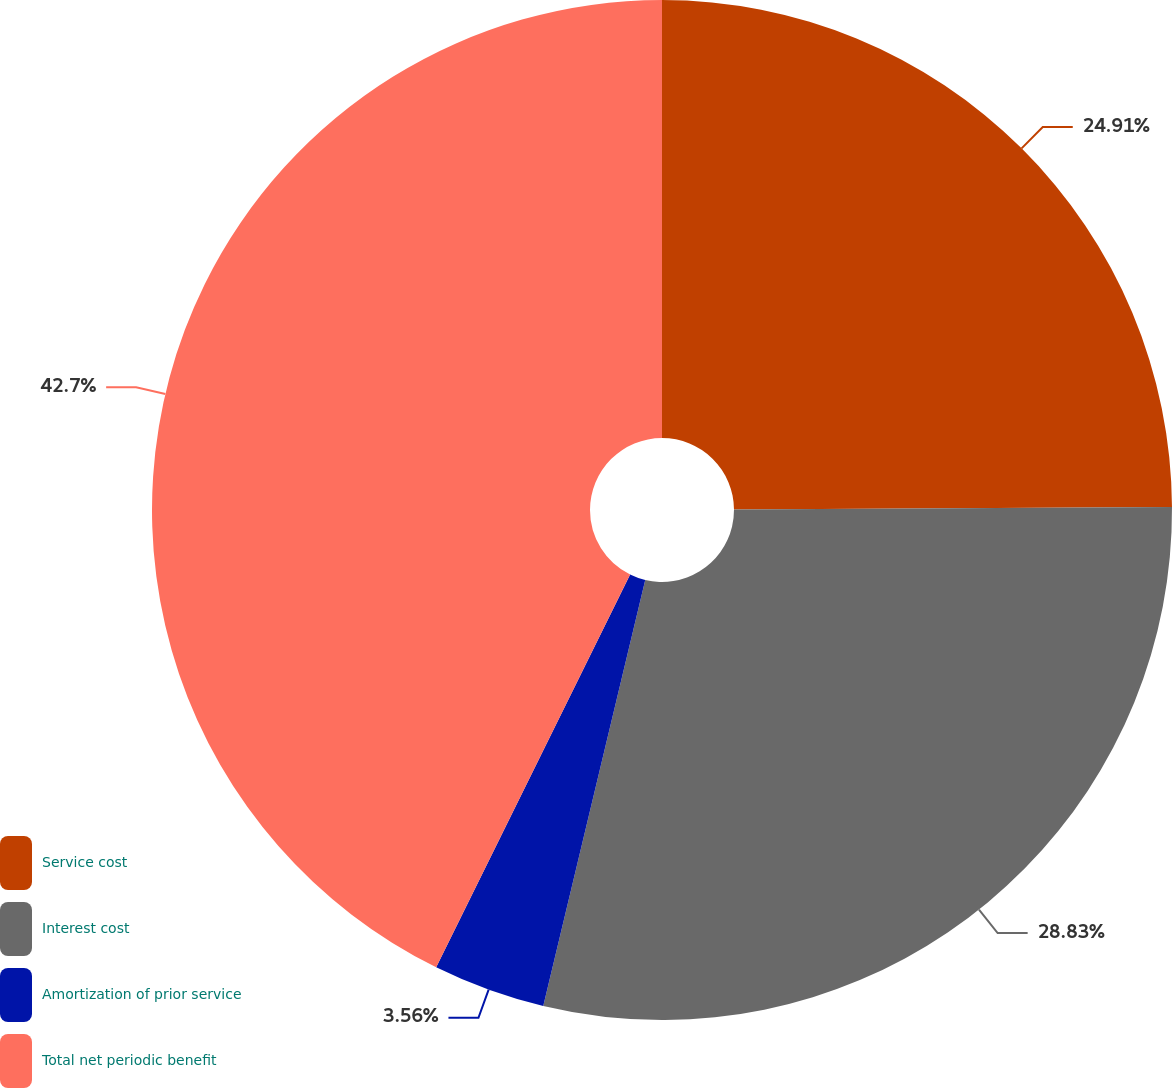Convert chart. <chart><loc_0><loc_0><loc_500><loc_500><pie_chart><fcel>Service cost<fcel>Interest cost<fcel>Amortization of prior service<fcel>Total net periodic benefit<nl><fcel>24.91%<fcel>28.83%<fcel>3.56%<fcel>42.7%<nl></chart> 